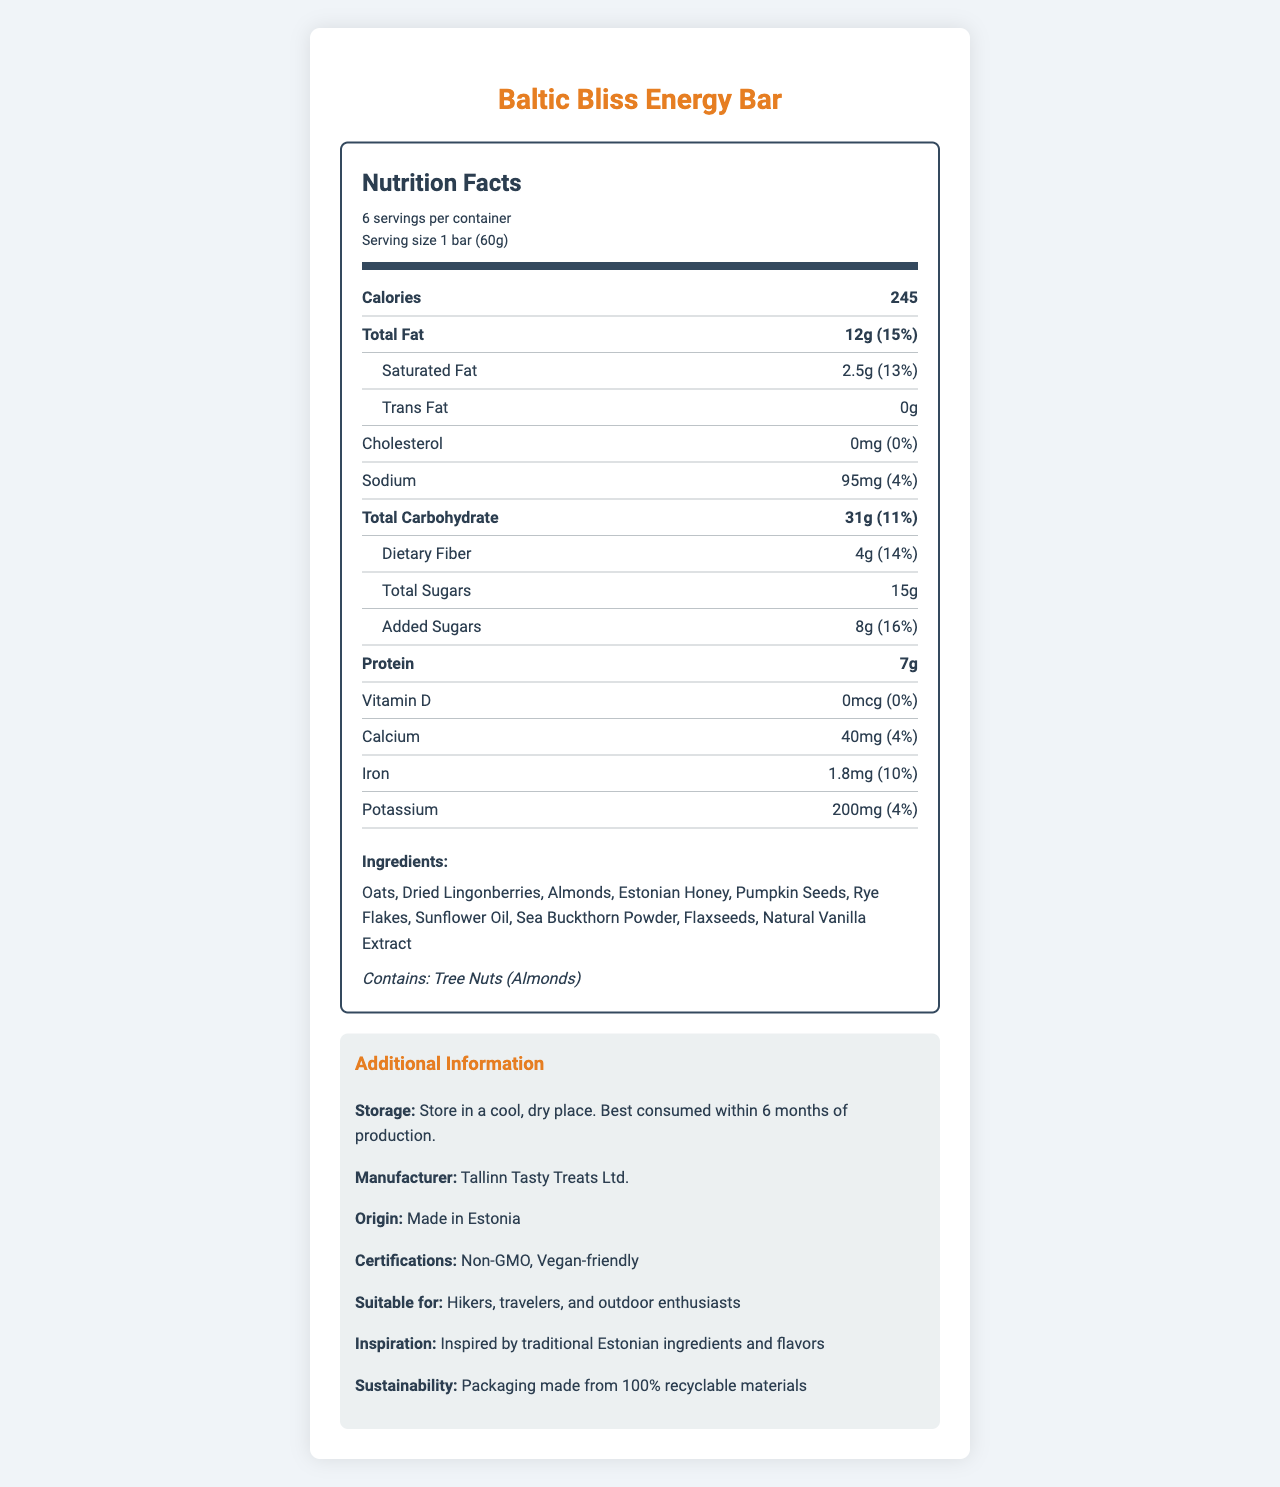how many calories are in one serving of the Baltic Bliss Energy Bar? The document states that each bar, which is one serving, contains 245 calories.
Answer: 245 what is the serving size of the Baltic Bliss Energy Bar? The document lists the serving size as 1 bar (60g).
Answer: 1 bar (60g) what is the total fat content per serving? According to the document, the total fat content per serving is 12g.
Answer: 12g how much protein does one bar contain? The document mentions that one bar contains 7g of protein.
Answer: 7g what is the main allergen listed for this energy bar? The allergens section states that the product contains tree nuts (almonds).
Answer: Tree Nuts (Almonds) what percentage of the daily value of dietary fiber does one bar provide? The document states that one bar provides 14% of the daily value of dietary fiber.
Answer: 14% which of the following is NOT an ingredient in the Baltic Bliss Energy Bar? A. Dried Lingonberries B. Sea Buckthorn Powder C. Coconut Oil D. Flaxseeds The document lists the ingredients, and Coconut Oil is not mentioned among them.
Answer: C. Coconut Oil what is the source of inspiration for the Baltic Bliss Energy Bar? A. Traditional Estonian Ingredients and Flavors B. American Energy Bars C. Mediterranean Diet D. Asian Cuisine The additional info section states the inspiration as "Inspired by traditional Estonian ingredients and flavors."
Answer: A. Traditional Estonian Ingredients and Flavors is the Baltic Bliss Energy Bar vegan-friendly? The document lists "Vegan-friendly" as one of the certifications.
Answer: Yes where is the Baltic Bliss Energy Bar made? The origin section indicates that the bar is made in Estonia.
Answer: Estonia what kind of packaging is used for the Baltic Bliss Energy Bar, from a sustainability perspective? The additional info section mentions that the packaging is made from 100% recyclable materials.
Answer: 100% recyclable materials are there any trans fats in the Baltic Bliss Energy Bar? The document clearly states that the trans fat content is 0g.
Answer: No how many servings are there in one container? The serving info section states that there are 6 servings per container.
Answer: 6 summarize the key features and nutritional contents of the Baltic Bliss Energy Bar. The document provides comprehensive information about the bar's nutritional values, key ingredients, certifications, suitability for certain users, and its eco-friendly packaging.
Answer: The Baltic Bliss Energy Bar is an Estonian-inspired energy bar made for travelers and hikers. It contains 245 calories per serving and key ingredients like oats, dried lingonberries, and Estonian honey. It provides 12g of total fat, 7g of protein, 31g of carbohydrates, and is vegan-friendly. The bar is also rich in dietary fiber (4g) and uses sustainable packaging. how much vitamin D is in one serving of the Baltic Bliss Energy Bar? The nutritional facts section lists vitamin D content as 0mcg.
Answer: 0mcg what company manufactures the Baltic Bliss Energy Bar? The additional info section states that the manufacturer is Tallinn Tasty Treats Ltd.
Answer: Tallinn Tasty Treats Ltd. how many milligrams of calcium does one bar contain? The document lists the calcium content as 40mg per bar.
Answer: 40mg is it possible to determine how much omega-3 fatty acids are present in the Baltic Bliss Energy Bar? The document does not provide details on the content of omega-3 fatty acids.
Answer: Not enough information 